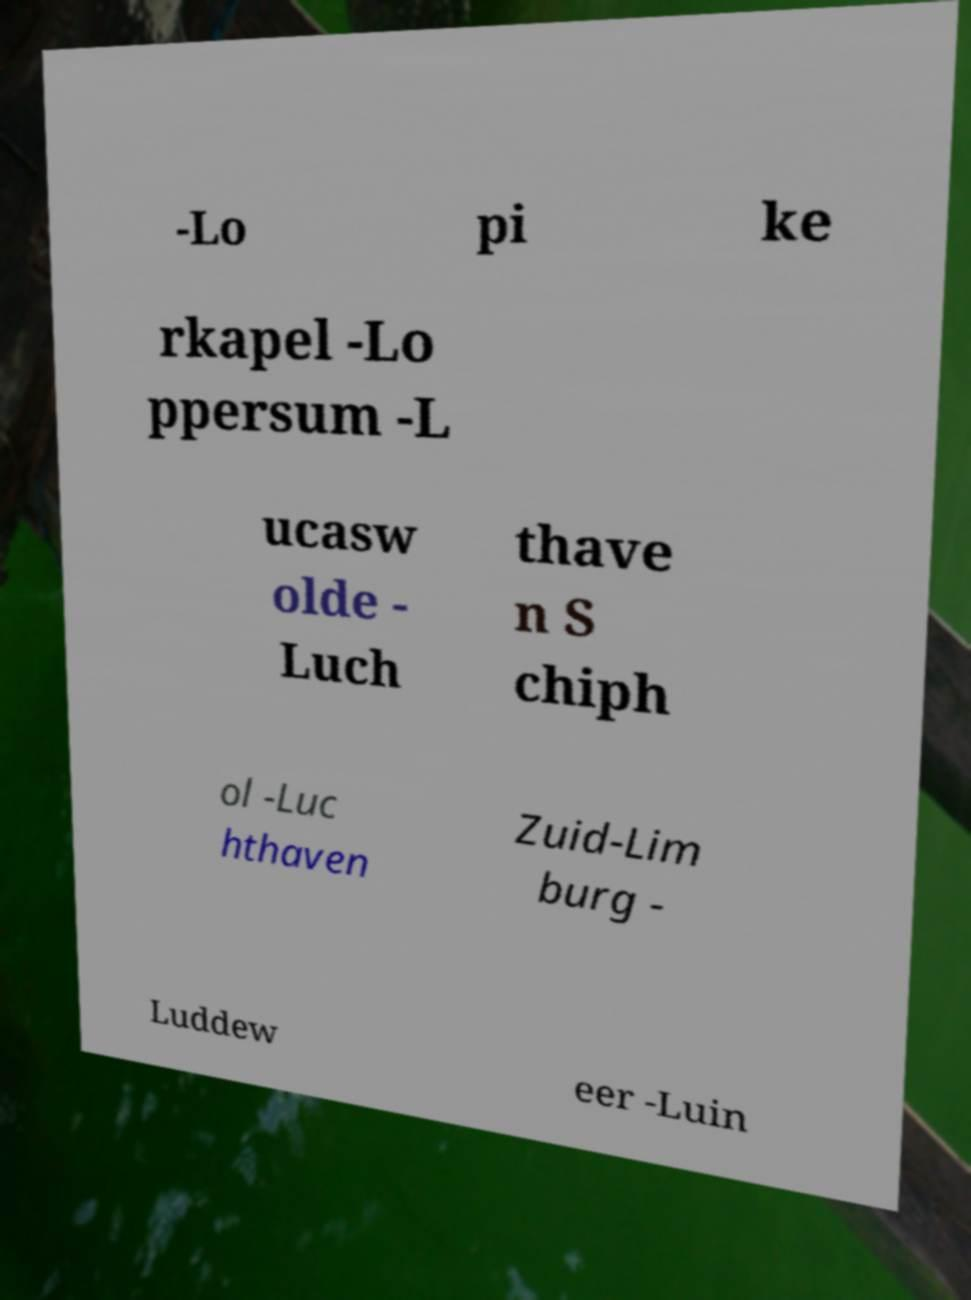Can you read and provide the text displayed in the image?This photo seems to have some interesting text. Can you extract and type it out for me? -Lo pi ke rkapel -Lo ppersum -L ucasw olde - Luch thave n S chiph ol -Luc hthaven Zuid-Lim burg - Luddew eer -Luin 